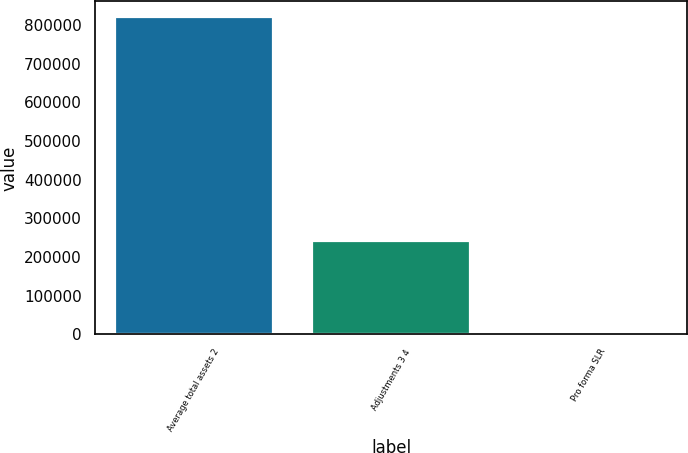<chart> <loc_0><loc_0><loc_500><loc_500><bar_chart><fcel>Average total assets 2<fcel>Adjustments 3 4<fcel>Pro forma SLR<nl><fcel>820536<fcel>240999<fcel>6.2<nl></chart> 